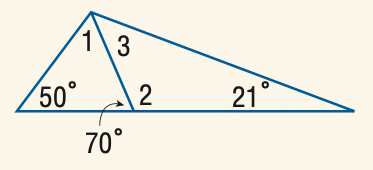Answer the mathemtical geometry problem and directly provide the correct option letter.
Question: Find the measure of \angle 3.
Choices: A: 49 B: 50 C: 60 D: 70 A 